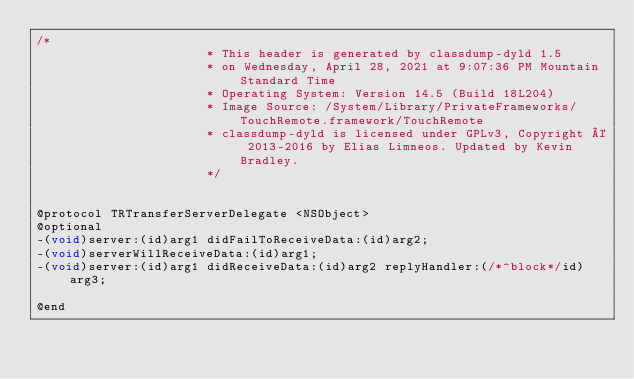<code> <loc_0><loc_0><loc_500><loc_500><_C_>/*
                       * This header is generated by classdump-dyld 1.5
                       * on Wednesday, April 28, 2021 at 9:07:36 PM Mountain Standard Time
                       * Operating System: Version 14.5 (Build 18L204)
                       * Image Source: /System/Library/PrivateFrameworks/TouchRemote.framework/TouchRemote
                       * classdump-dyld is licensed under GPLv3, Copyright © 2013-2016 by Elias Limneos. Updated by Kevin Bradley.
                       */


@protocol TRTransferServerDelegate <NSObject>
@optional
-(void)server:(id)arg1 didFailToReceiveData:(id)arg2;
-(void)serverWillReceiveData:(id)arg1;
-(void)server:(id)arg1 didReceiveData:(id)arg2 replyHandler:(/*^block*/id)arg3;

@end

</code> 